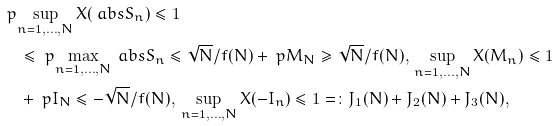<formula> <loc_0><loc_0><loc_500><loc_500>& \ p { \sup _ { n = 1 , \dots , N } X ( \ a b s { S _ { n } } ) \leq 1 } \\ & \quad \leq \ p { \max _ { n = 1 , \dots , N } \ a b s { S _ { n } } \leq \sqrt { N } / f ( N ) } + \ p { M _ { N } \geq \sqrt { N } / f ( N ) , \, \sup _ { n = 1 , \dots , N } X ( M _ { n } ) \leq 1 } \\ & \quad + \ p { I _ { N } \leq - \sqrt { N } / f ( N ) , \, \sup _ { n = 1 , \dots , N } X ( - I _ { n } ) \leq 1 } = \colon J _ { 1 } ( N ) + J _ { 2 } ( N ) + J _ { 3 } ( N ) ,</formula> 